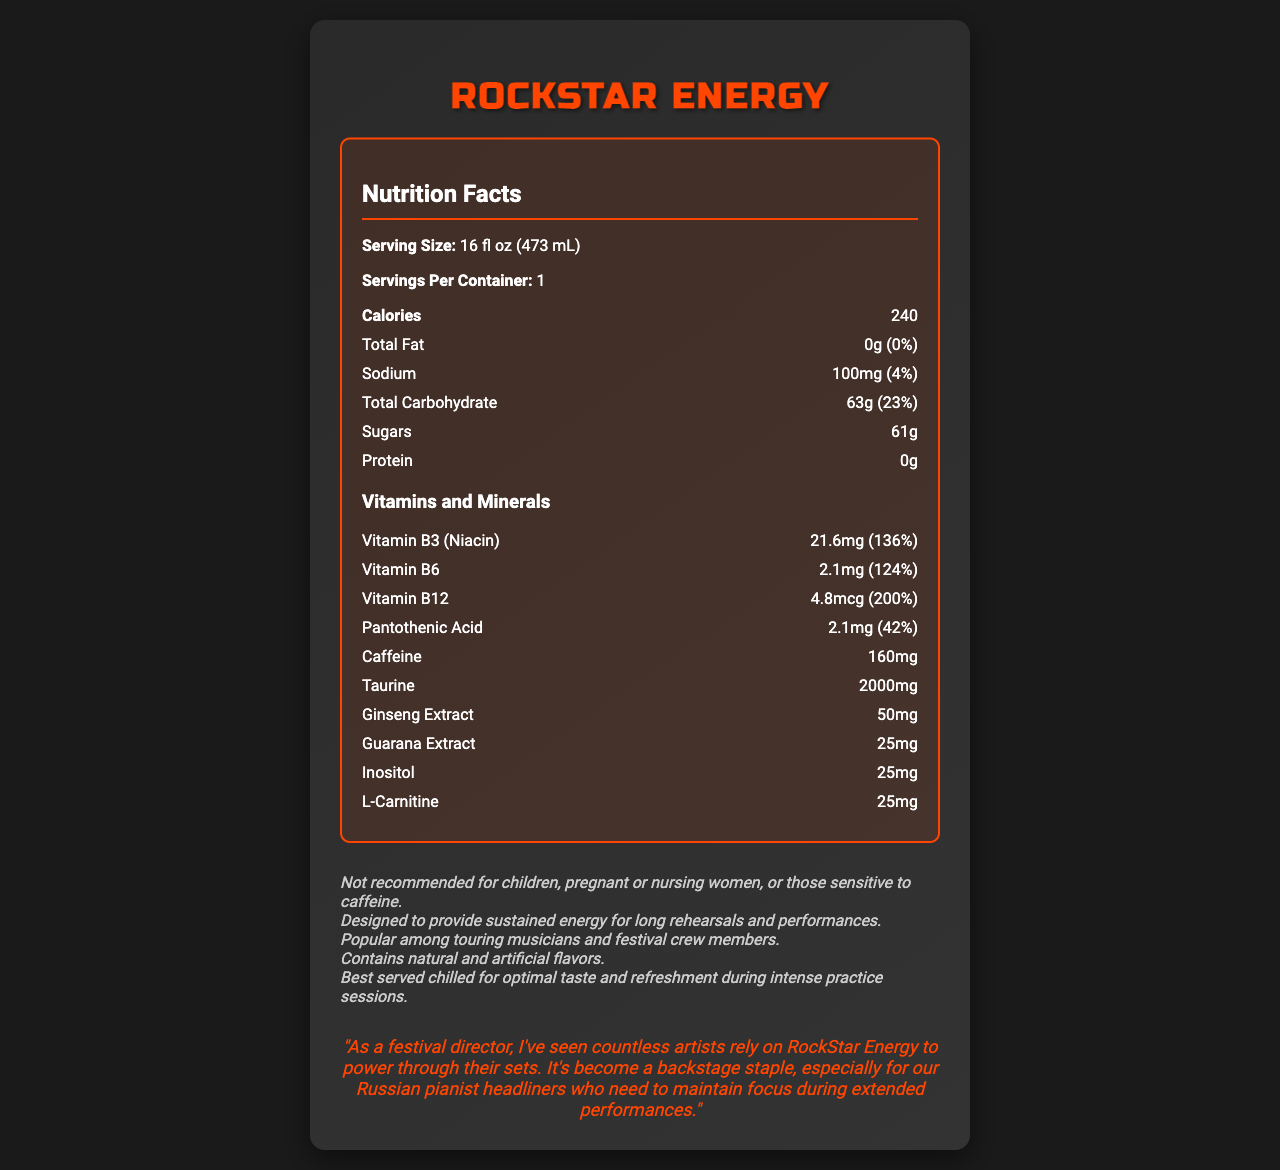what is the serving size of RockStar Energy? The serving size is clearly specified in the document under the nutrition facts section.
Answer: 16 fl oz (473 mL) how many calories are in one serving of RockStar Energy? The document states that each serving contains 240 calories.
Answer: 240 what is the amount of total fat in RockStar Energy? The total fat content is listed as 0g, which is also 0% of the daily value.
Answer: 0g what percentage of the daily value of sodium does RockStar Energy provide? The sodium content is stated as 100mg, which is 4% of the daily value.
Answer: 4% what is the total carbohydrate content in RockStar Energy? The total carbohydrate is listed as 63g, which is 23% of the daily value.
Answer: 63g how much caffeine is in RockStar Energy? The document lists caffeine content as 160mg.
Answer: 160mg which vitamin has the highest daily value percentage in RockStar Energy? A. Vitamin B3 (Niacin) B. Vitamin B6 C. Vitamin B12 D. Pantothenic Acid Vitamin B12 has the highest daily value percentage at 200%.
Answer: C. Vitamin B12 how many grams of sugar are in RockStar Energy? A. 50g B. 55g C. 61g D. 63g The document specifies that there are 61g of sugar in RockStar Energy.
Answer: C. 61g is there any protein in RockStar Energy? The document states that the protein content is 0g.
Answer: No is RockStar Energy recommended for children? The document includes a note saying it is not recommended for children.
Answer: No describe the main idea of the document The document includes both nutritional facts and additional consumption insights, focusing on its popularity among musicians and its energy-boosting properties.
Answer: The document provides detailed nutritional information for RockStar Energy, an energy drink popular among musicians. It lists the contents such as calories, fats, sugars, vitamins, minerals, and specific ingredients like caffeine and taurine. Additional information includes consumption recommendations and testimonials from musicians. what is the manufacturing date of RockStar Energy? The document does not provide any information about the manufacturing date.
Answer: Not enough information what are some of the main ingredients in RockStar Energy? These ingredients are listed individually in the nutrition facts section.
Answer: Caffeine, Taurine, Ginseng Extract, Guarana Extract, Inositol, L-Carnitine which vitamin in RockStar Energy provides 136% of the daily value? Vitamin B3 (Niacin) is listed as providing 136% of the daily value.
Answer: Vitamin B3 (Niacin) 